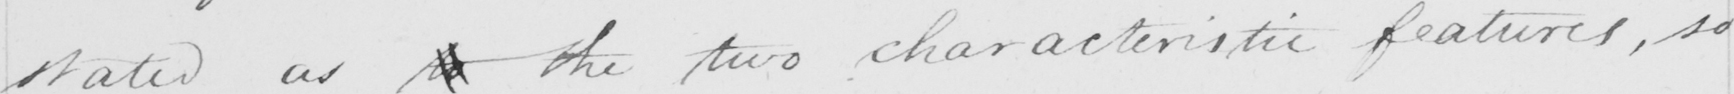Can you tell me what this handwritten text says? stated as to the two characteristic features , so 